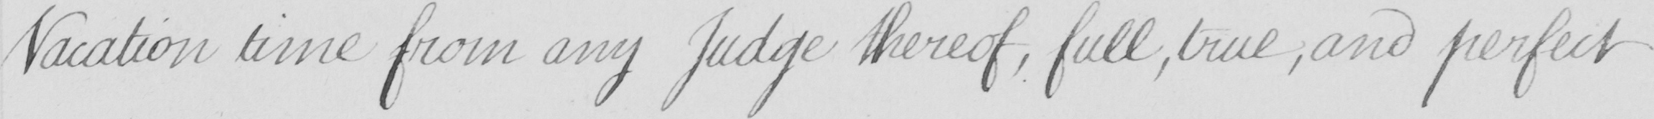Please transcribe the handwritten text in this image. Vacation time from any Judge thereof , full , true , and perfect 